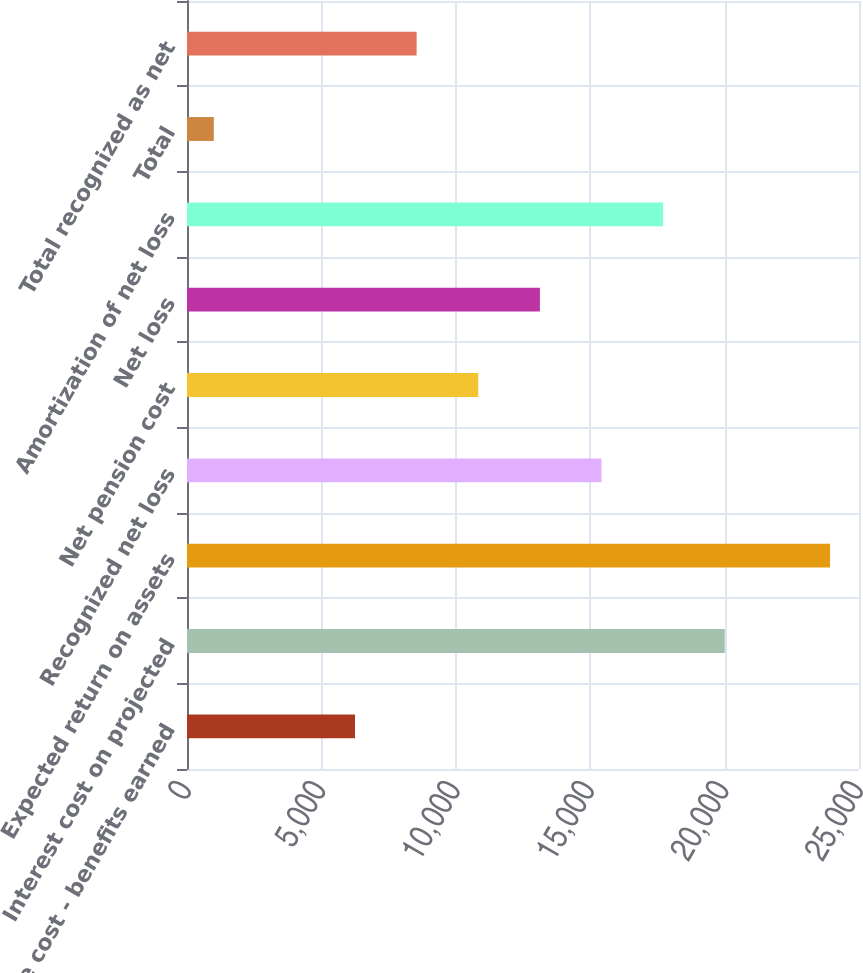<chart> <loc_0><loc_0><loc_500><loc_500><bar_chart><fcel>Service cost - benefits earned<fcel>Interest cost on projected<fcel>Expected return on assets<fcel>Recognized net loss<fcel>Net pension cost<fcel>Net loss<fcel>Amortization of net loss<fcel>Total<fcel>Total recognized as net<nl><fcel>6250<fcel>20006.2<fcel>23923<fcel>15420.8<fcel>10835.4<fcel>13128.1<fcel>17713.5<fcel>996<fcel>8542.7<nl></chart> 